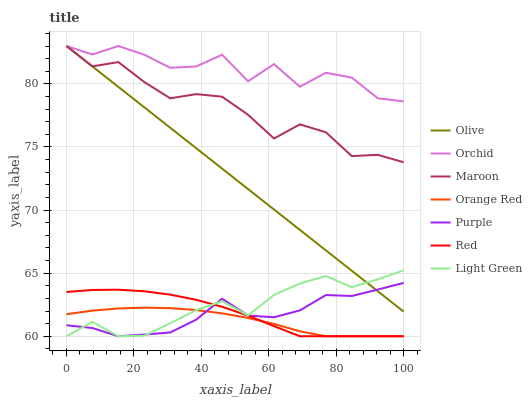Does Orange Red have the minimum area under the curve?
Answer yes or no. Yes. Does Orchid have the maximum area under the curve?
Answer yes or no. Yes. Does Maroon have the minimum area under the curve?
Answer yes or no. No. Does Maroon have the maximum area under the curve?
Answer yes or no. No. Is Olive the smoothest?
Answer yes or no. Yes. Is Orchid the roughest?
Answer yes or no. Yes. Is Maroon the smoothest?
Answer yes or no. No. Is Maroon the roughest?
Answer yes or no. No. Does Purple have the lowest value?
Answer yes or no. Yes. Does Maroon have the lowest value?
Answer yes or no. No. Does Orchid have the highest value?
Answer yes or no. Yes. Does Light Green have the highest value?
Answer yes or no. No. Is Purple less than Maroon?
Answer yes or no. Yes. Is Olive greater than Red?
Answer yes or no. Yes. Does Purple intersect Red?
Answer yes or no. Yes. Is Purple less than Red?
Answer yes or no. No. Is Purple greater than Red?
Answer yes or no. No. Does Purple intersect Maroon?
Answer yes or no. No. 